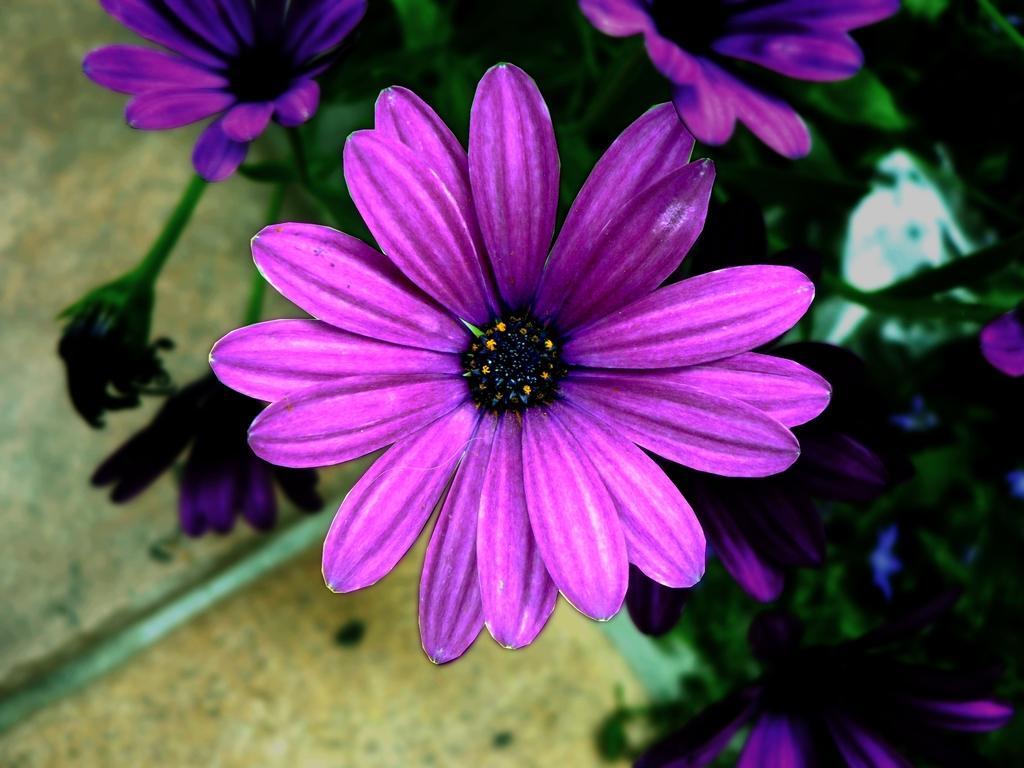In one or two sentences, can you explain what this image depicts? In this image we can see there are plants with flowers and the ground at the bottom. 